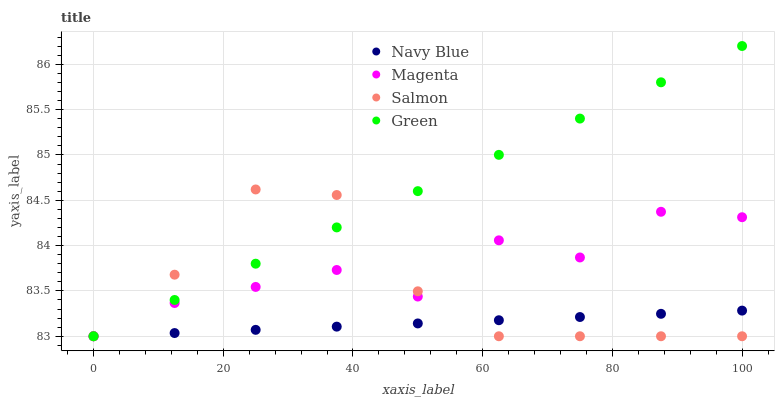Does Navy Blue have the minimum area under the curve?
Answer yes or no. Yes. Does Green have the maximum area under the curve?
Answer yes or no. Yes. Does Magenta have the minimum area under the curve?
Answer yes or no. No. Does Magenta have the maximum area under the curve?
Answer yes or no. No. Is Navy Blue the smoothest?
Answer yes or no. Yes. Is Magenta the roughest?
Answer yes or no. Yes. Is Green the smoothest?
Answer yes or no. No. Is Green the roughest?
Answer yes or no. No. Does Navy Blue have the lowest value?
Answer yes or no. Yes. Does Green have the highest value?
Answer yes or no. Yes. Does Magenta have the highest value?
Answer yes or no. No. Does Salmon intersect Magenta?
Answer yes or no. Yes. Is Salmon less than Magenta?
Answer yes or no. No. Is Salmon greater than Magenta?
Answer yes or no. No. 